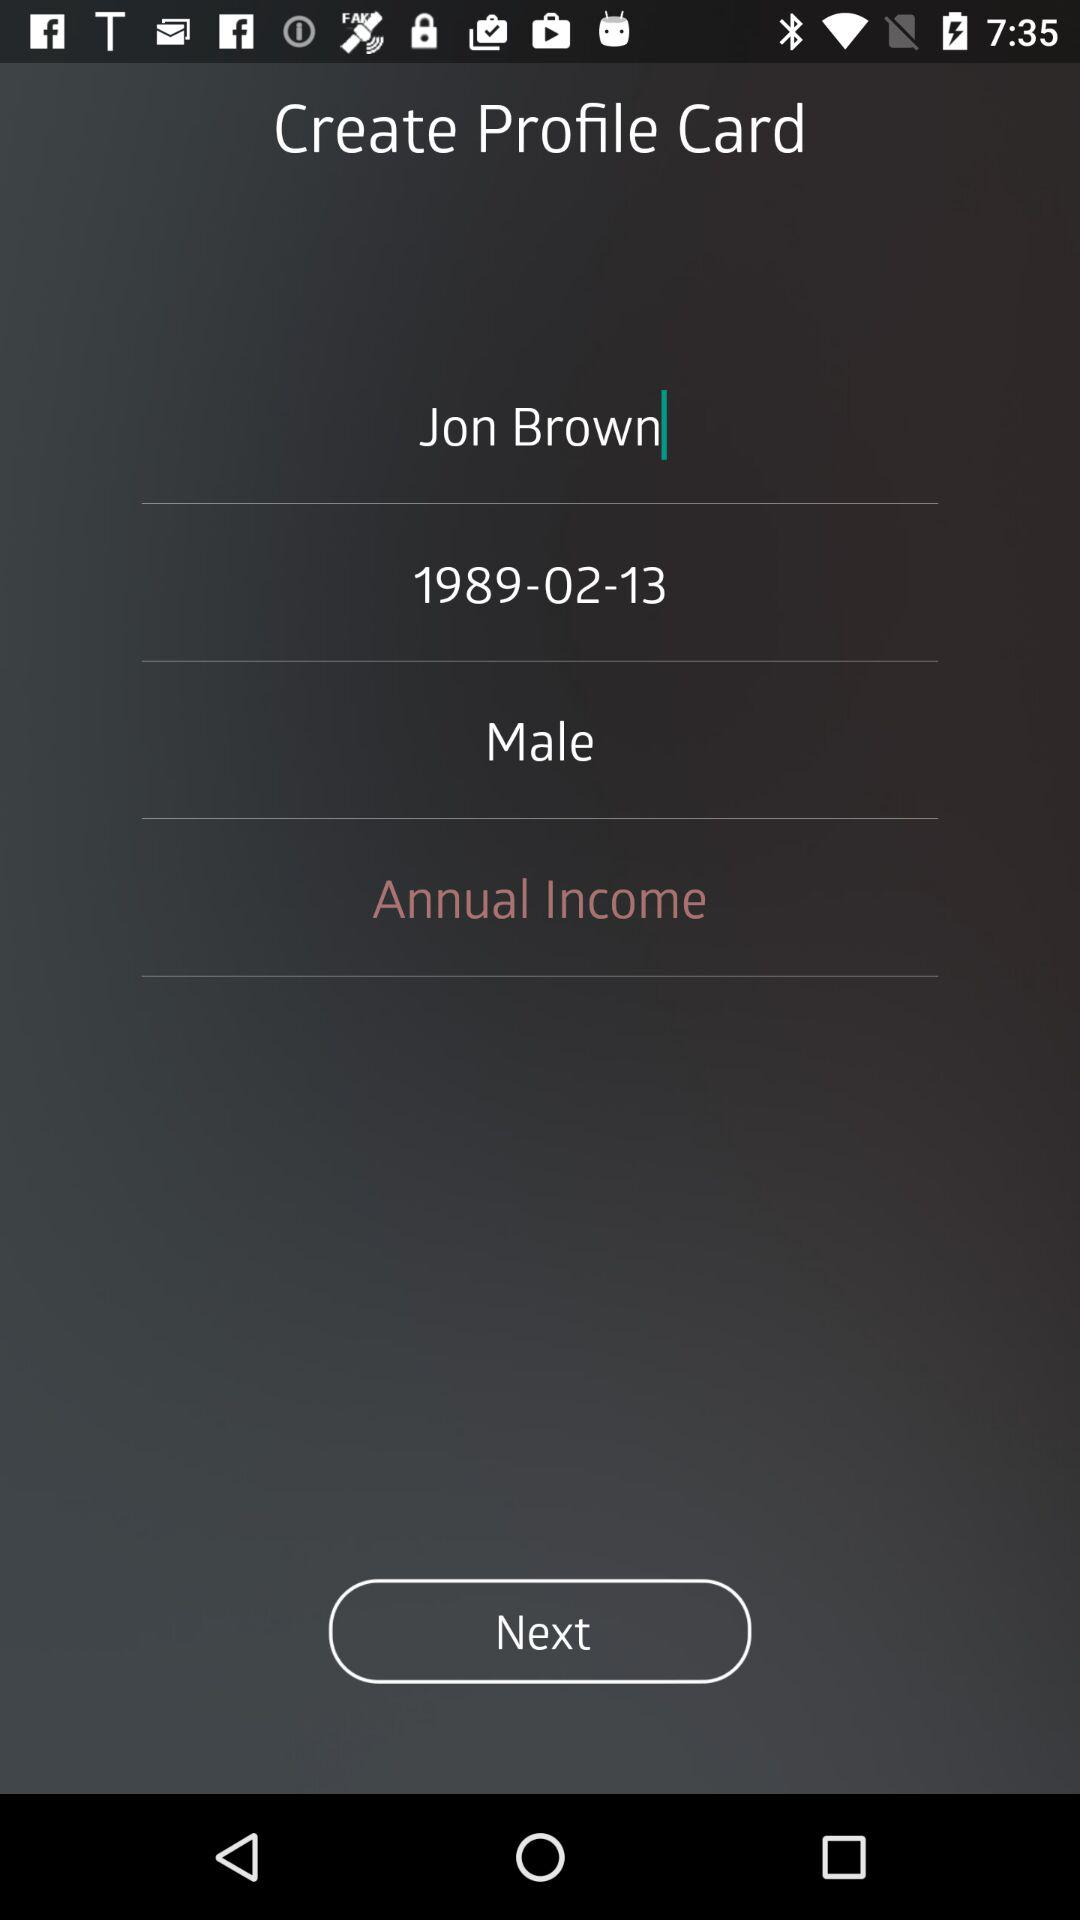What is the gender of Jon Brown? The gender is male. 